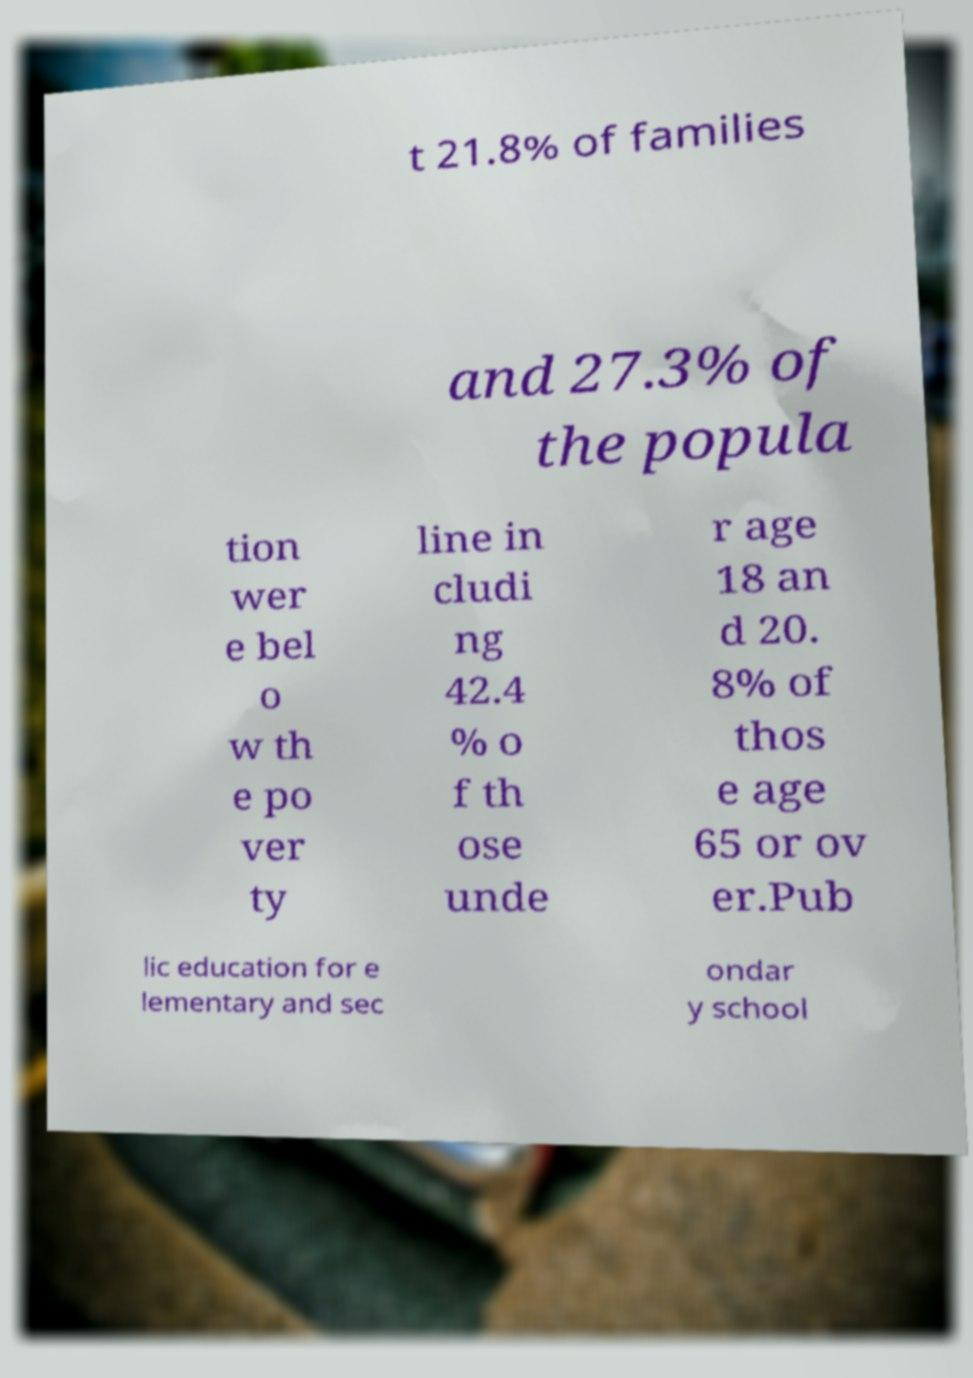Can you read and provide the text displayed in the image?This photo seems to have some interesting text. Can you extract and type it out for me? t 21.8% of families and 27.3% of the popula tion wer e bel o w th e po ver ty line in cludi ng 42.4 % o f th ose unde r age 18 an d 20. 8% of thos e age 65 or ov er.Pub lic education for e lementary and sec ondar y school 